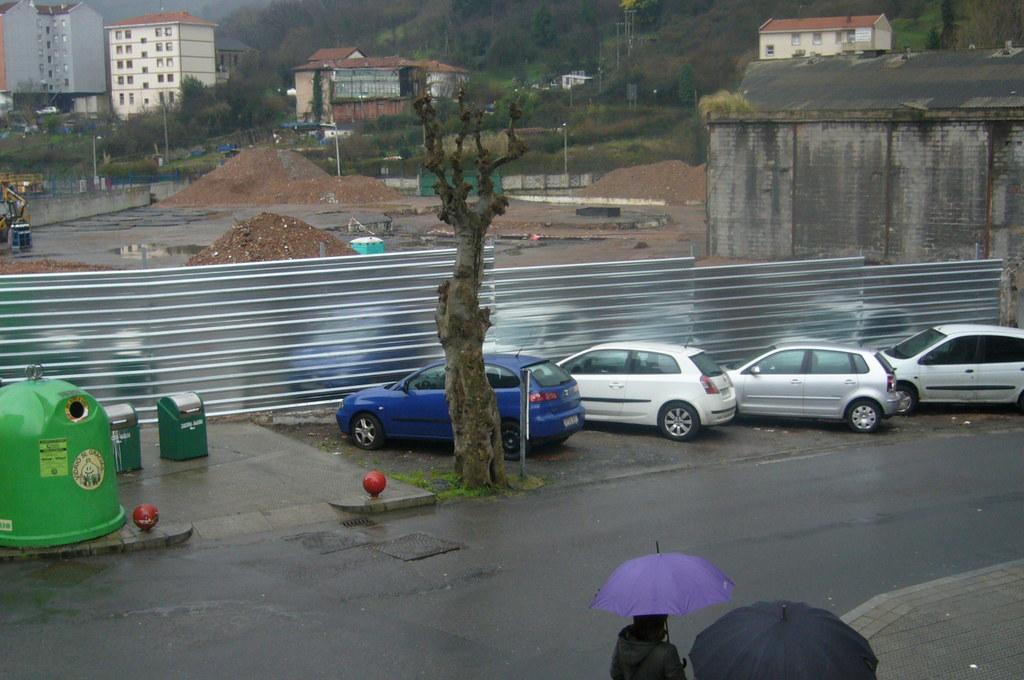In one or two sentences, can you explain what this image depicts? In the image there are few cars parked beside a wall made up of some metal sheets and behind the wall some construction work is going on and around that area there are many buildings and houses, in between the houses there are many trees and plants. Besides the cars there is a dry tree and on the footpath two people were walking along with the umbrellas. Beside the cars there are two dustbins. 